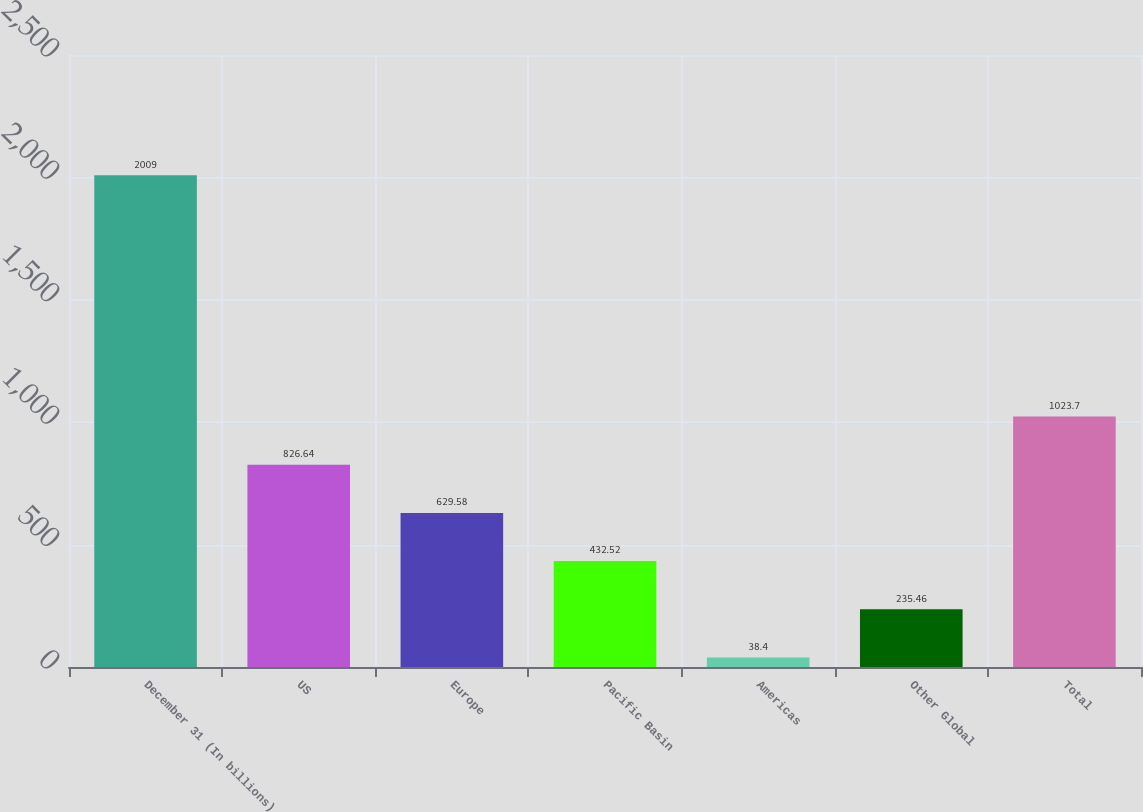Convert chart to OTSL. <chart><loc_0><loc_0><loc_500><loc_500><bar_chart><fcel>December 31 (In billions)<fcel>US<fcel>Europe<fcel>Pacific Basin<fcel>Americas<fcel>Other Global<fcel>Total<nl><fcel>2009<fcel>826.64<fcel>629.58<fcel>432.52<fcel>38.4<fcel>235.46<fcel>1023.7<nl></chart> 